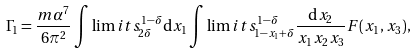Convert formula to latex. <formula><loc_0><loc_0><loc_500><loc_500>\Gamma _ { 1 } = \frac { m \alpha ^ { 7 } } { 6 \pi ^ { 2 } } \int \lim i t s ^ { 1 - \delta } _ { 2 \delta } { \mathrm d } x _ { 1 } \int \lim i t s ^ { 1 - \delta } _ { 1 - x _ { 1 } + \delta } \frac { { \mathrm d } x _ { 2 } } { x _ { 1 } x _ { 2 } x _ { 3 } } F ( x _ { 1 } , x _ { 3 } ) ,</formula> 